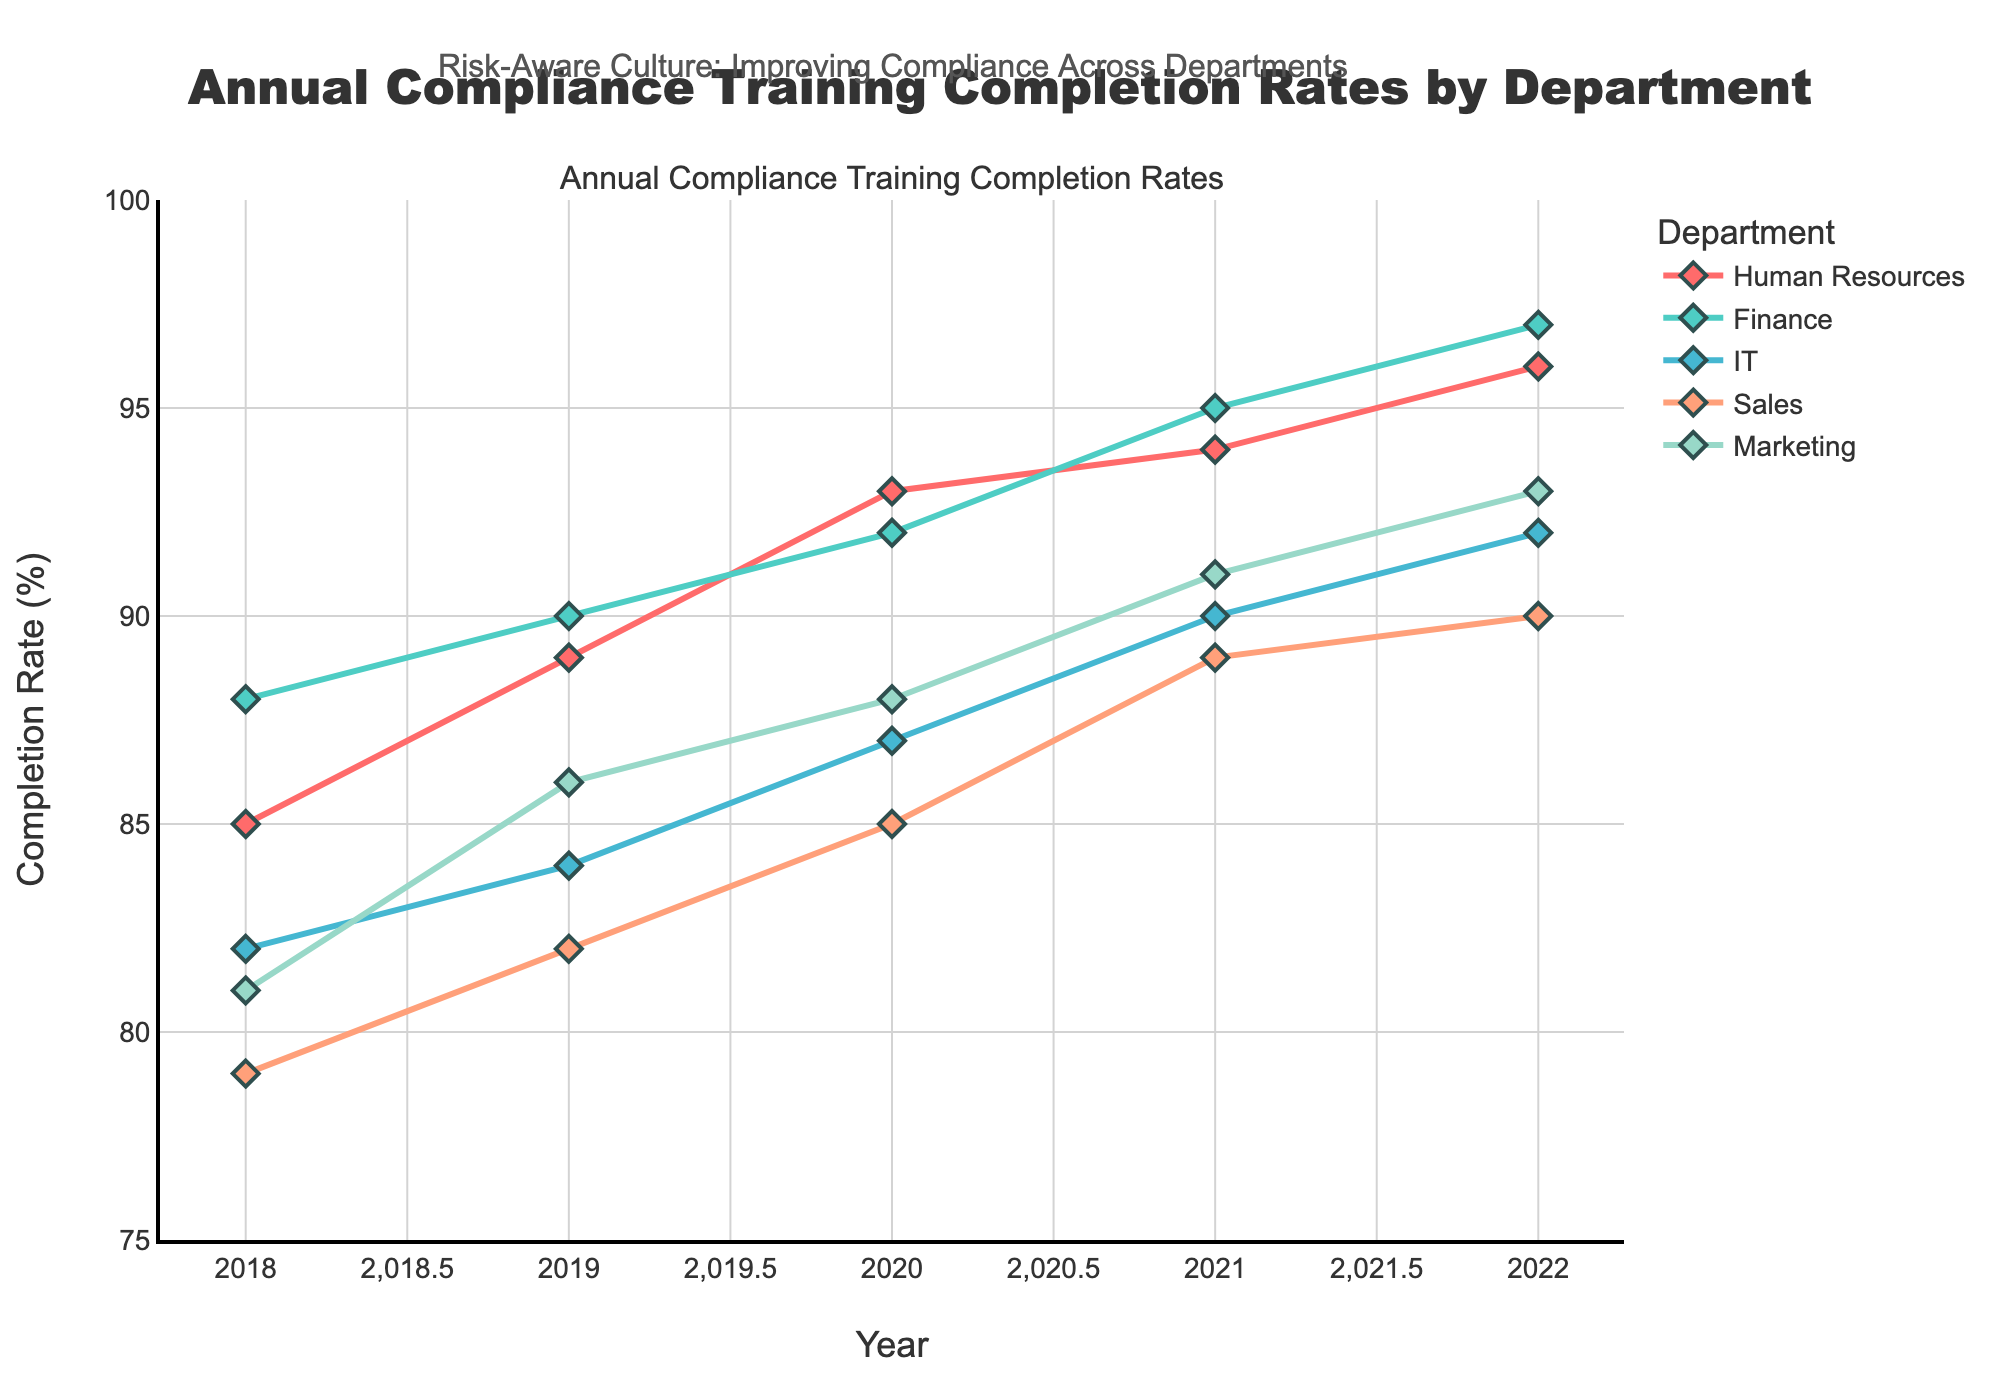What is the title of the figure? The title is typically located at the top of the figure. In this case, the title reads, "Annual Compliance Training Completion Rates by Department."
Answer: Annual Compliance Training Completion Rates by Department What is the completion rate for the Sales department in 2020? Locate the data point for the year 2020 along the x-axis and then find the completion rate for the Sales department. The corresponding rate on the y-axis for Sales in 2020 is marked as 85.
Answer: 85 Which department had the highest compliance training completion rate in 2022? Look at the completion rates for all departments in the year 2022 on the x-axis. Finance has the highest rate, with a completion rate of 97.
Answer: Finance By how much did the completion rate of the Marketing department increase from 2018 to 2022? Find the completion rates for the Marketing department in 2018 and 2022 on the y-axis. Subtract the 2018 rate (81) from the 2022 rate (93) to find the increase.
Answer: 12 Which department showed the most consistent increase in compliance training completion rates over the years? Examine the trend lines of the departments. The Finance department’s completion rate consistently increases each year, suggesting the most consistent improvement.
Answer: Finance Compare the completion rate of the IT department between 2018 and 2021. Which year had the higher rate? Find the completion rates for the IT department in 2018 and 2021 on the y-axis. The completion rate in 2018 is 82, and in 2021 it is 90, making 2021 higher.
Answer: 2021 What trend can be observed in the Human Resources department's completion rates from 2018 to 2022? Observe the trend line for the Human Resources department. The completion rate steadily increases from 85 in 2018 to 96 in 2022.
Answer: Increasing What is the average completion rate for the Finance department across all the years shown? Add the completion rates for the Finance department for all years (88, 90, 92, 95, 97) and then divide by the number of years, which is 5. (88 + 90 + 92 + 95 + 97) / 5 = 92.4.
Answer: 92.4 Which year marks the lowest completion rate for any department, and which department does it belong to? Scan all the data points and identify the lowest rate, which is 79 for the Sales department in 2018.
Answer: 2018, Sales Between the years 2019 and 2020, which department had the smallest increase in completion rates? Calculate the increase for each department between 2019 and 2020. The IT department has the smallest increase from 84 to 87, which is an increase of 3.
Answer: IT 